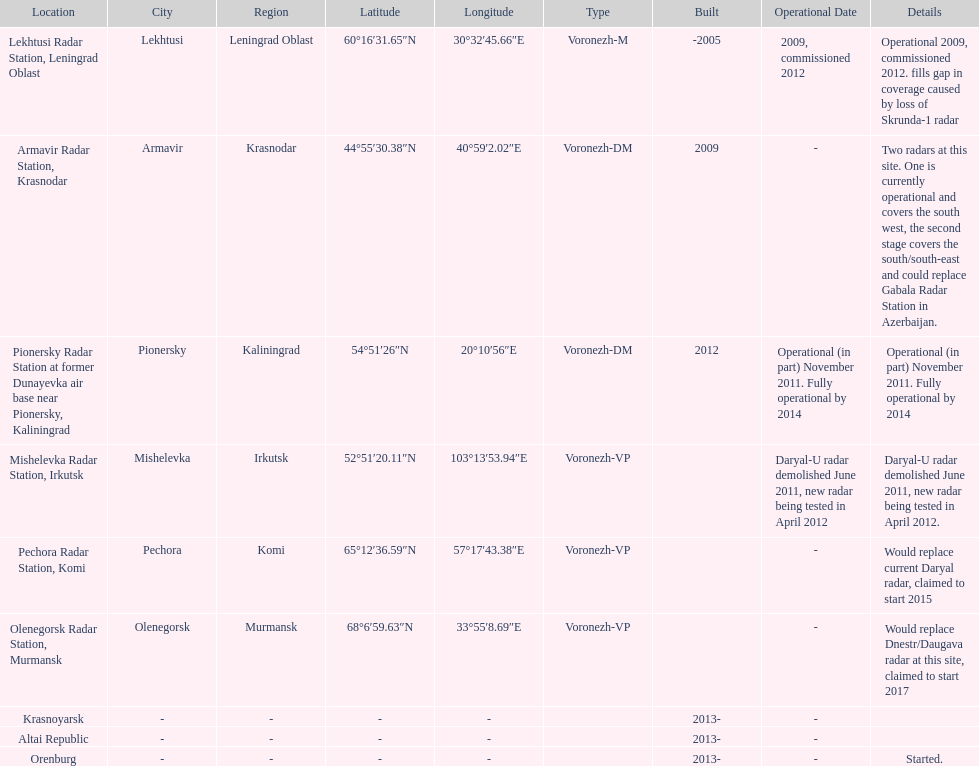What is the only radar that will start in 2015? Pechora Radar Station, Komi. 